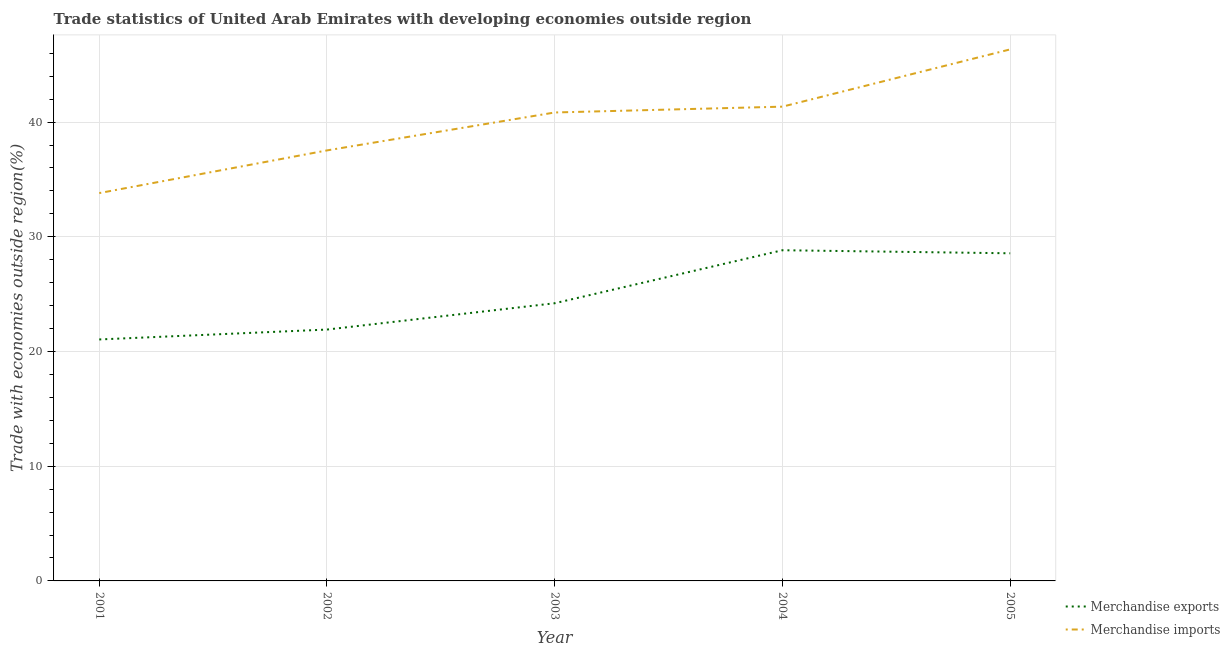How many different coloured lines are there?
Your response must be concise. 2. Does the line corresponding to merchandise imports intersect with the line corresponding to merchandise exports?
Offer a very short reply. No. Is the number of lines equal to the number of legend labels?
Provide a short and direct response. Yes. What is the merchandise imports in 2002?
Keep it short and to the point. 37.53. Across all years, what is the maximum merchandise imports?
Provide a succinct answer. 46.34. Across all years, what is the minimum merchandise imports?
Provide a succinct answer. 33.81. In which year was the merchandise exports maximum?
Provide a short and direct response. 2004. What is the total merchandise exports in the graph?
Your answer should be very brief. 124.56. What is the difference between the merchandise imports in 2003 and that in 2004?
Offer a very short reply. -0.51. What is the difference between the merchandise imports in 2004 and the merchandise exports in 2001?
Give a very brief answer. 20.29. What is the average merchandise imports per year?
Keep it short and to the point. 39.97. In the year 2005, what is the difference between the merchandise imports and merchandise exports?
Offer a terse response. 17.78. In how many years, is the merchandise imports greater than 26 %?
Your response must be concise. 5. What is the ratio of the merchandise imports in 2004 to that in 2005?
Your answer should be very brief. 0.89. Is the difference between the merchandise imports in 2001 and 2005 greater than the difference between the merchandise exports in 2001 and 2005?
Give a very brief answer. No. What is the difference between the highest and the second highest merchandise exports?
Offer a terse response. 0.27. What is the difference between the highest and the lowest merchandise imports?
Your response must be concise. 12.53. In how many years, is the merchandise exports greater than the average merchandise exports taken over all years?
Give a very brief answer. 2. Does the merchandise imports monotonically increase over the years?
Your answer should be very brief. Yes. How many lines are there?
Ensure brevity in your answer.  2. What is the difference between two consecutive major ticks on the Y-axis?
Make the answer very short. 10. Are the values on the major ticks of Y-axis written in scientific E-notation?
Provide a short and direct response. No. Does the graph contain grids?
Provide a short and direct response. Yes. Where does the legend appear in the graph?
Give a very brief answer. Bottom right. How many legend labels are there?
Keep it short and to the point. 2. How are the legend labels stacked?
Make the answer very short. Vertical. What is the title of the graph?
Make the answer very short. Trade statistics of United Arab Emirates with developing economies outside region. What is the label or title of the X-axis?
Offer a terse response. Year. What is the label or title of the Y-axis?
Keep it short and to the point. Trade with economies outside region(%). What is the Trade with economies outside region(%) in Merchandise exports in 2001?
Offer a very short reply. 21.05. What is the Trade with economies outside region(%) of Merchandise imports in 2001?
Offer a terse response. 33.81. What is the Trade with economies outside region(%) of Merchandise exports in 2002?
Provide a succinct answer. 21.91. What is the Trade with economies outside region(%) in Merchandise imports in 2002?
Provide a short and direct response. 37.53. What is the Trade with economies outside region(%) of Merchandise exports in 2003?
Provide a short and direct response. 24.21. What is the Trade with economies outside region(%) of Merchandise imports in 2003?
Offer a very short reply. 40.84. What is the Trade with economies outside region(%) of Merchandise exports in 2004?
Offer a terse response. 28.83. What is the Trade with economies outside region(%) in Merchandise imports in 2004?
Offer a terse response. 41.35. What is the Trade with economies outside region(%) of Merchandise exports in 2005?
Offer a terse response. 28.56. What is the Trade with economies outside region(%) of Merchandise imports in 2005?
Offer a terse response. 46.34. Across all years, what is the maximum Trade with economies outside region(%) in Merchandise exports?
Your response must be concise. 28.83. Across all years, what is the maximum Trade with economies outside region(%) in Merchandise imports?
Provide a succinct answer. 46.34. Across all years, what is the minimum Trade with economies outside region(%) in Merchandise exports?
Make the answer very short. 21.05. Across all years, what is the minimum Trade with economies outside region(%) in Merchandise imports?
Ensure brevity in your answer.  33.81. What is the total Trade with economies outside region(%) in Merchandise exports in the graph?
Provide a succinct answer. 124.56. What is the total Trade with economies outside region(%) of Merchandise imports in the graph?
Give a very brief answer. 199.86. What is the difference between the Trade with economies outside region(%) of Merchandise exports in 2001 and that in 2002?
Your response must be concise. -0.86. What is the difference between the Trade with economies outside region(%) in Merchandise imports in 2001 and that in 2002?
Offer a very short reply. -3.72. What is the difference between the Trade with economies outside region(%) of Merchandise exports in 2001 and that in 2003?
Make the answer very short. -3.16. What is the difference between the Trade with economies outside region(%) of Merchandise imports in 2001 and that in 2003?
Provide a succinct answer. -7.03. What is the difference between the Trade with economies outside region(%) in Merchandise exports in 2001 and that in 2004?
Your response must be concise. -7.78. What is the difference between the Trade with economies outside region(%) of Merchandise imports in 2001 and that in 2004?
Your answer should be very brief. -7.54. What is the difference between the Trade with economies outside region(%) of Merchandise exports in 2001 and that in 2005?
Your response must be concise. -7.51. What is the difference between the Trade with economies outside region(%) of Merchandise imports in 2001 and that in 2005?
Offer a terse response. -12.53. What is the difference between the Trade with economies outside region(%) in Merchandise exports in 2002 and that in 2003?
Make the answer very short. -2.29. What is the difference between the Trade with economies outside region(%) in Merchandise imports in 2002 and that in 2003?
Your response must be concise. -3.31. What is the difference between the Trade with economies outside region(%) of Merchandise exports in 2002 and that in 2004?
Offer a terse response. -6.92. What is the difference between the Trade with economies outside region(%) in Merchandise imports in 2002 and that in 2004?
Give a very brief answer. -3.81. What is the difference between the Trade with economies outside region(%) in Merchandise exports in 2002 and that in 2005?
Offer a terse response. -6.65. What is the difference between the Trade with economies outside region(%) in Merchandise imports in 2002 and that in 2005?
Provide a succinct answer. -8.81. What is the difference between the Trade with economies outside region(%) of Merchandise exports in 2003 and that in 2004?
Your response must be concise. -4.62. What is the difference between the Trade with economies outside region(%) of Merchandise imports in 2003 and that in 2004?
Provide a succinct answer. -0.51. What is the difference between the Trade with economies outside region(%) of Merchandise exports in 2003 and that in 2005?
Provide a succinct answer. -4.35. What is the difference between the Trade with economies outside region(%) of Merchandise imports in 2003 and that in 2005?
Offer a very short reply. -5.5. What is the difference between the Trade with economies outside region(%) of Merchandise exports in 2004 and that in 2005?
Keep it short and to the point. 0.27. What is the difference between the Trade with economies outside region(%) in Merchandise imports in 2004 and that in 2005?
Provide a succinct answer. -4.99. What is the difference between the Trade with economies outside region(%) of Merchandise exports in 2001 and the Trade with economies outside region(%) of Merchandise imports in 2002?
Provide a short and direct response. -16.48. What is the difference between the Trade with economies outside region(%) of Merchandise exports in 2001 and the Trade with economies outside region(%) of Merchandise imports in 2003?
Keep it short and to the point. -19.79. What is the difference between the Trade with economies outside region(%) of Merchandise exports in 2001 and the Trade with economies outside region(%) of Merchandise imports in 2004?
Your answer should be compact. -20.29. What is the difference between the Trade with economies outside region(%) in Merchandise exports in 2001 and the Trade with economies outside region(%) in Merchandise imports in 2005?
Make the answer very short. -25.29. What is the difference between the Trade with economies outside region(%) in Merchandise exports in 2002 and the Trade with economies outside region(%) in Merchandise imports in 2003?
Offer a very short reply. -18.92. What is the difference between the Trade with economies outside region(%) of Merchandise exports in 2002 and the Trade with economies outside region(%) of Merchandise imports in 2004?
Keep it short and to the point. -19.43. What is the difference between the Trade with economies outside region(%) of Merchandise exports in 2002 and the Trade with economies outside region(%) of Merchandise imports in 2005?
Your response must be concise. -24.42. What is the difference between the Trade with economies outside region(%) of Merchandise exports in 2003 and the Trade with economies outside region(%) of Merchandise imports in 2004?
Make the answer very short. -17.14. What is the difference between the Trade with economies outside region(%) in Merchandise exports in 2003 and the Trade with economies outside region(%) in Merchandise imports in 2005?
Your response must be concise. -22.13. What is the difference between the Trade with economies outside region(%) of Merchandise exports in 2004 and the Trade with economies outside region(%) of Merchandise imports in 2005?
Make the answer very short. -17.51. What is the average Trade with economies outside region(%) in Merchandise exports per year?
Your answer should be very brief. 24.91. What is the average Trade with economies outside region(%) in Merchandise imports per year?
Offer a terse response. 39.97. In the year 2001, what is the difference between the Trade with economies outside region(%) of Merchandise exports and Trade with economies outside region(%) of Merchandise imports?
Your answer should be very brief. -12.76. In the year 2002, what is the difference between the Trade with economies outside region(%) of Merchandise exports and Trade with economies outside region(%) of Merchandise imports?
Provide a succinct answer. -15.62. In the year 2003, what is the difference between the Trade with economies outside region(%) in Merchandise exports and Trade with economies outside region(%) in Merchandise imports?
Your response must be concise. -16.63. In the year 2004, what is the difference between the Trade with economies outside region(%) in Merchandise exports and Trade with economies outside region(%) in Merchandise imports?
Provide a succinct answer. -12.52. In the year 2005, what is the difference between the Trade with economies outside region(%) of Merchandise exports and Trade with economies outside region(%) of Merchandise imports?
Provide a short and direct response. -17.78. What is the ratio of the Trade with economies outside region(%) of Merchandise exports in 2001 to that in 2002?
Make the answer very short. 0.96. What is the ratio of the Trade with economies outside region(%) in Merchandise imports in 2001 to that in 2002?
Your answer should be very brief. 0.9. What is the ratio of the Trade with economies outside region(%) of Merchandise exports in 2001 to that in 2003?
Ensure brevity in your answer.  0.87. What is the ratio of the Trade with economies outside region(%) of Merchandise imports in 2001 to that in 2003?
Provide a short and direct response. 0.83. What is the ratio of the Trade with economies outside region(%) in Merchandise exports in 2001 to that in 2004?
Your response must be concise. 0.73. What is the ratio of the Trade with economies outside region(%) of Merchandise imports in 2001 to that in 2004?
Ensure brevity in your answer.  0.82. What is the ratio of the Trade with economies outside region(%) in Merchandise exports in 2001 to that in 2005?
Provide a short and direct response. 0.74. What is the ratio of the Trade with economies outside region(%) of Merchandise imports in 2001 to that in 2005?
Offer a very short reply. 0.73. What is the ratio of the Trade with economies outside region(%) in Merchandise exports in 2002 to that in 2003?
Keep it short and to the point. 0.91. What is the ratio of the Trade with economies outside region(%) of Merchandise imports in 2002 to that in 2003?
Offer a very short reply. 0.92. What is the ratio of the Trade with economies outside region(%) of Merchandise exports in 2002 to that in 2004?
Provide a succinct answer. 0.76. What is the ratio of the Trade with economies outside region(%) in Merchandise imports in 2002 to that in 2004?
Your answer should be very brief. 0.91. What is the ratio of the Trade with economies outside region(%) in Merchandise exports in 2002 to that in 2005?
Keep it short and to the point. 0.77. What is the ratio of the Trade with economies outside region(%) of Merchandise imports in 2002 to that in 2005?
Offer a very short reply. 0.81. What is the ratio of the Trade with economies outside region(%) of Merchandise exports in 2003 to that in 2004?
Your answer should be compact. 0.84. What is the ratio of the Trade with economies outside region(%) in Merchandise exports in 2003 to that in 2005?
Your answer should be very brief. 0.85. What is the ratio of the Trade with economies outside region(%) in Merchandise imports in 2003 to that in 2005?
Your response must be concise. 0.88. What is the ratio of the Trade with economies outside region(%) in Merchandise exports in 2004 to that in 2005?
Your answer should be very brief. 1.01. What is the ratio of the Trade with economies outside region(%) of Merchandise imports in 2004 to that in 2005?
Make the answer very short. 0.89. What is the difference between the highest and the second highest Trade with economies outside region(%) of Merchandise exports?
Provide a short and direct response. 0.27. What is the difference between the highest and the second highest Trade with economies outside region(%) of Merchandise imports?
Ensure brevity in your answer.  4.99. What is the difference between the highest and the lowest Trade with economies outside region(%) in Merchandise exports?
Provide a succinct answer. 7.78. What is the difference between the highest and the lowest Trade with economies outside region(%) in Merchandise imports?
Your response must be concise. 12.53. 